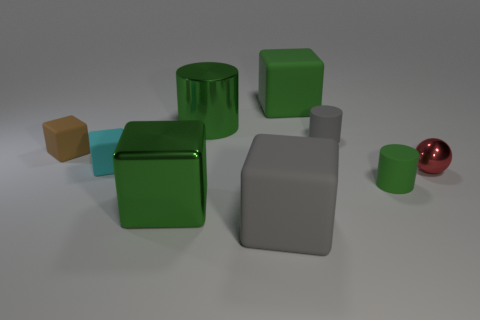Subtract all tiny matte cylinders. How many cylinders are left? 1 Subtract all gray spheres. How many green blocks are left? 2 Subtract 1 cylinders. How many cylinders are left? 2 Subtract all cyan blocks. How many blocks are left? 4 Subtract all balls. How many objects are left? 8 Add 1 gray rubber things. How many objects exist? 10 Subtract all green cubes. Subtract all gray balls. How many cubes are left? 3 Add 4 metallic objects. How many metallic objects are left? 7 Add 9 tiny red matte spheres. How many tiny red matte spheres exist? 9 Subtract 0 green balls. How many objects are left? 9 